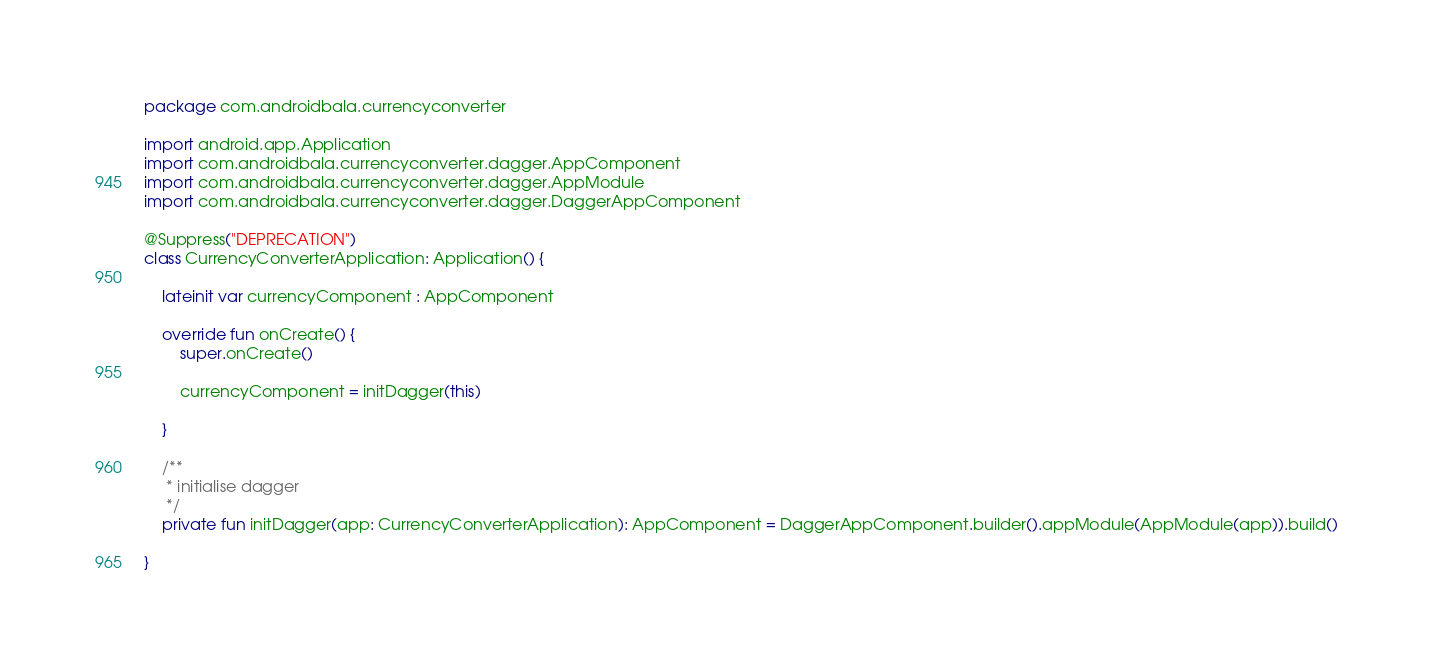Convert code to text. <code><loc_0><loc_0><loc_500><loc_500><_Kotlin_>package com.androidbala.currencyconverter

import android.app.Application
import com.androidbala.currencyconverter.dagger.AppComponent
import com.androidbala.currencyconverter.dagger.AppModule
import com.androidbala.currencyconverter.dagger.DaggerAppComponent

@Suppress("DEPRECATION")
class CurrencyConverterApplication: Application() {

    lateinit var currencyComponent : AppComponent

    override fun onCreate() {
        super.onCreate()

        currencyComponent = initDagger(this)

    }

    /**
     * initialise dagger
     */
    private fun initDagger(app: CurrencyConverterApplication): AppComponent = DaggerAppComponent.builder().appModule(AppModule(app)).build()

}</code> 